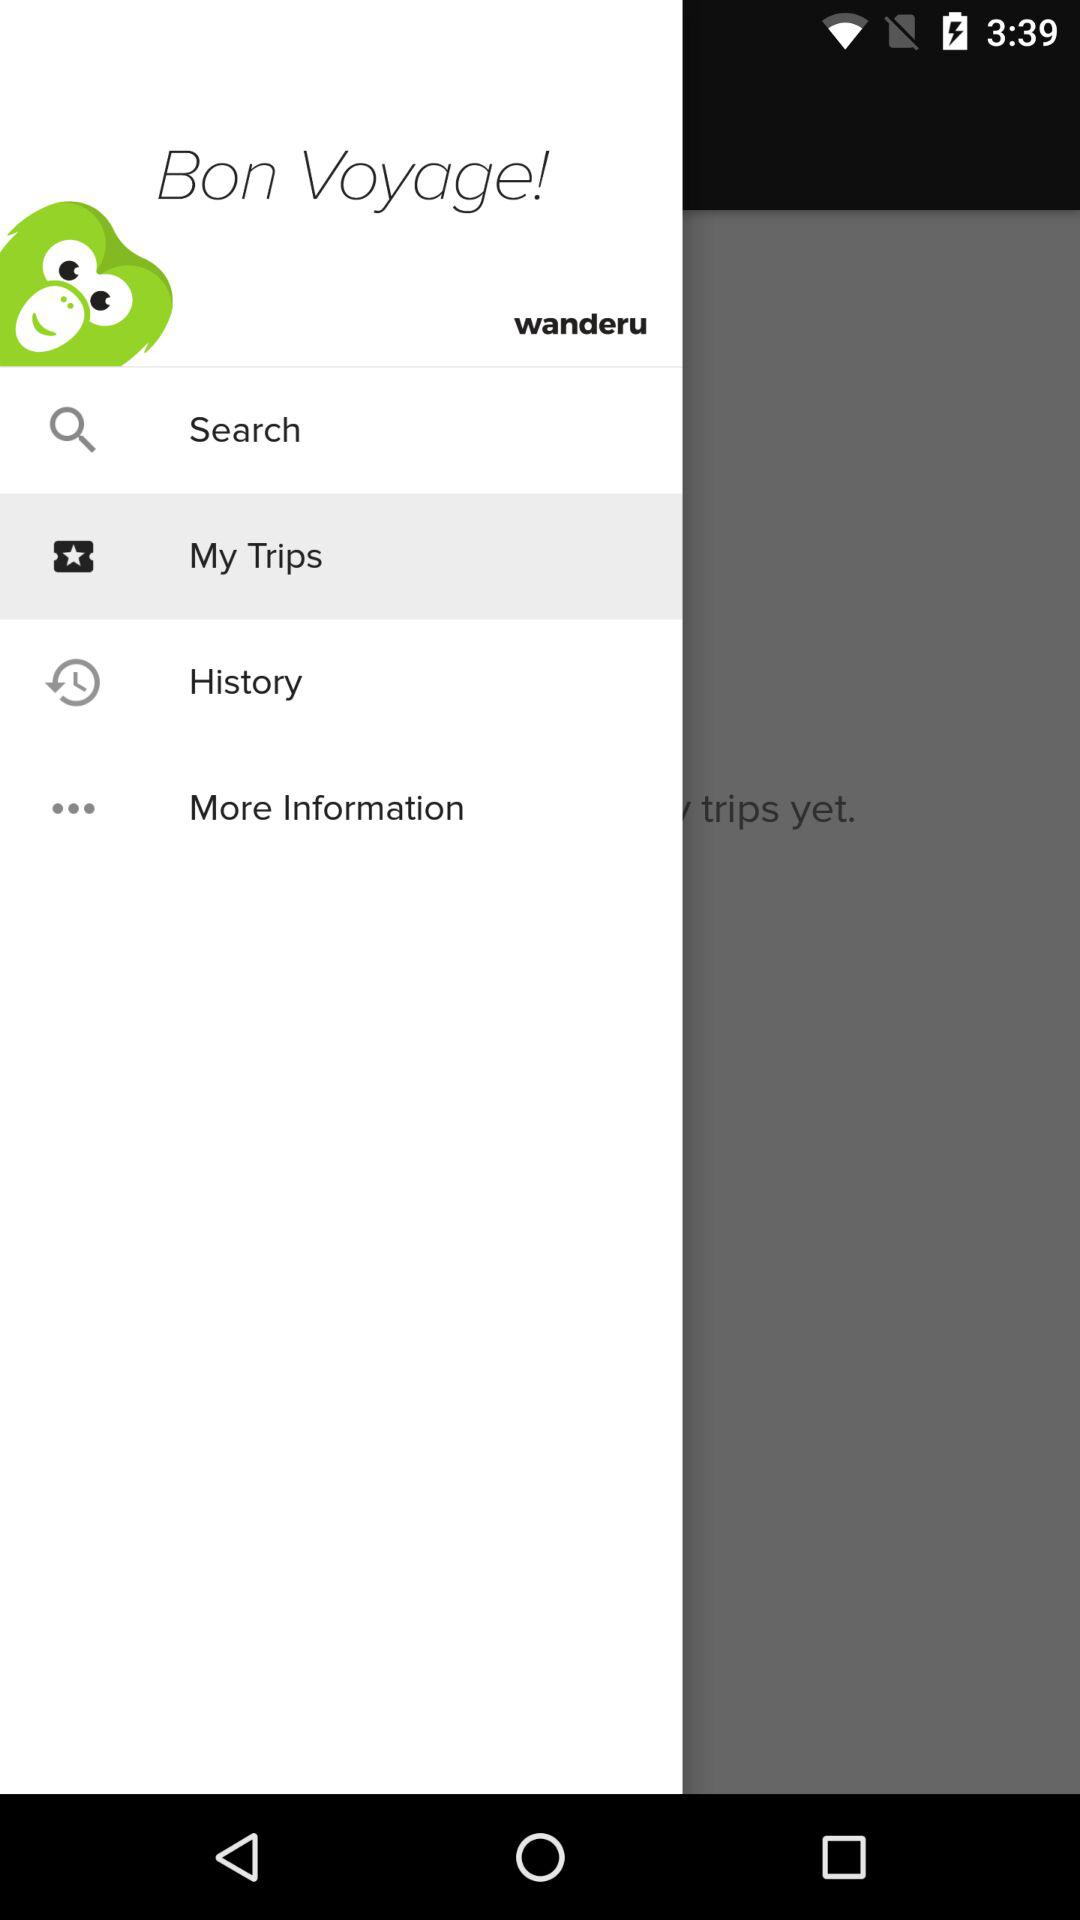What is the application name? The application name is "Bon Voyage". 